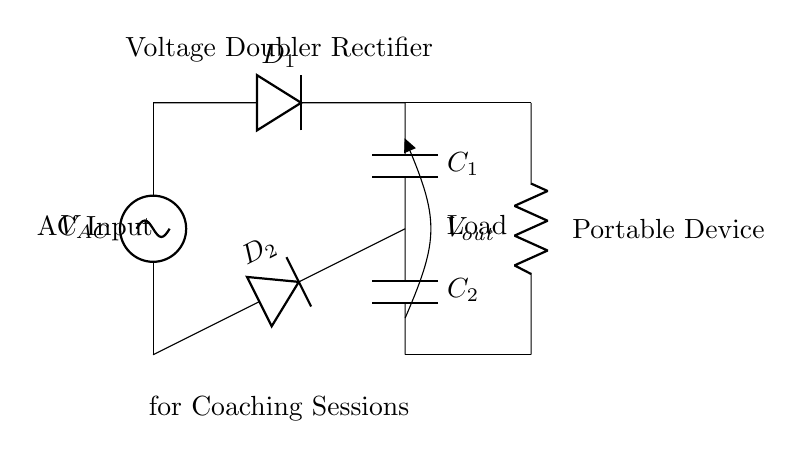What type of circuit is displayed? The circuit is identified as a voltage doubler rectifier circuit, which is typically used to convert alternating current to direct current while doubling the output voltage.
Answer: Voltage doubler rectifier What are the main components used in the circuit? The main components are two diodes, two capacitors, and a load resistor. The diodes allow current to flow in one direction, while the capacitors store charge to create the doubled voltage output.
Answer: Diodes, capacitors, load resistor What is the function of capacitor C1? Capacitor C1 is used to store charge during the positive half-cycle of the input AC voltage, which helps in generating a higher output voltage when combined with capacitor C2.
Answer: Store charge How many diodes are present in the circuit? There are two diodes in the circuit labeled as D1 and D2. Each diode plays a crucial role in rectifying the AC signal to DC.
Answer: Two What can be inferred about the output voltage level? The output voltage is approximately double the peak AC input voltage, as both capacitors work together to increase the potential difference in the circuit.
Answer: Double the peak input What is the purpose of using a load in this circuit? The load represents the device being powered by the rectifier circuit, and it helps illustrate the practical application of the voltage doubler in charging portable devices during coaching sessions.
Answer: To power a device 